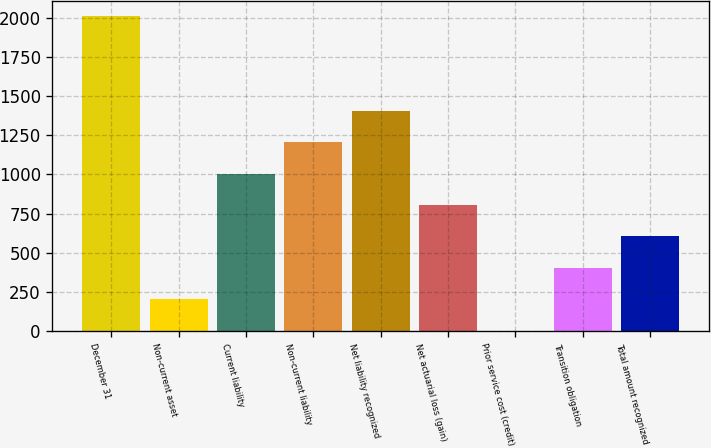<chart> <loc_0><loc_0><loc_500><loc_500><bar_chart><fcel>December 31<fcel>Non-current asset<fcel>Current liability<fcel>Non-current liability<fcel>Net liability recognized<fcel>Net actuarial loss (gain)<fcel>Prior service cost (credit)<fcel>Transition obligation<fcel>Total amount recognized<nl><fcel>2012<fcel>201.38<fcel>1006.1<fcel>1207.28<fcel>1408.46<fcel>804.92<fcel>0.2<fcel>402.56<fcel>603.74<nl></chart> 